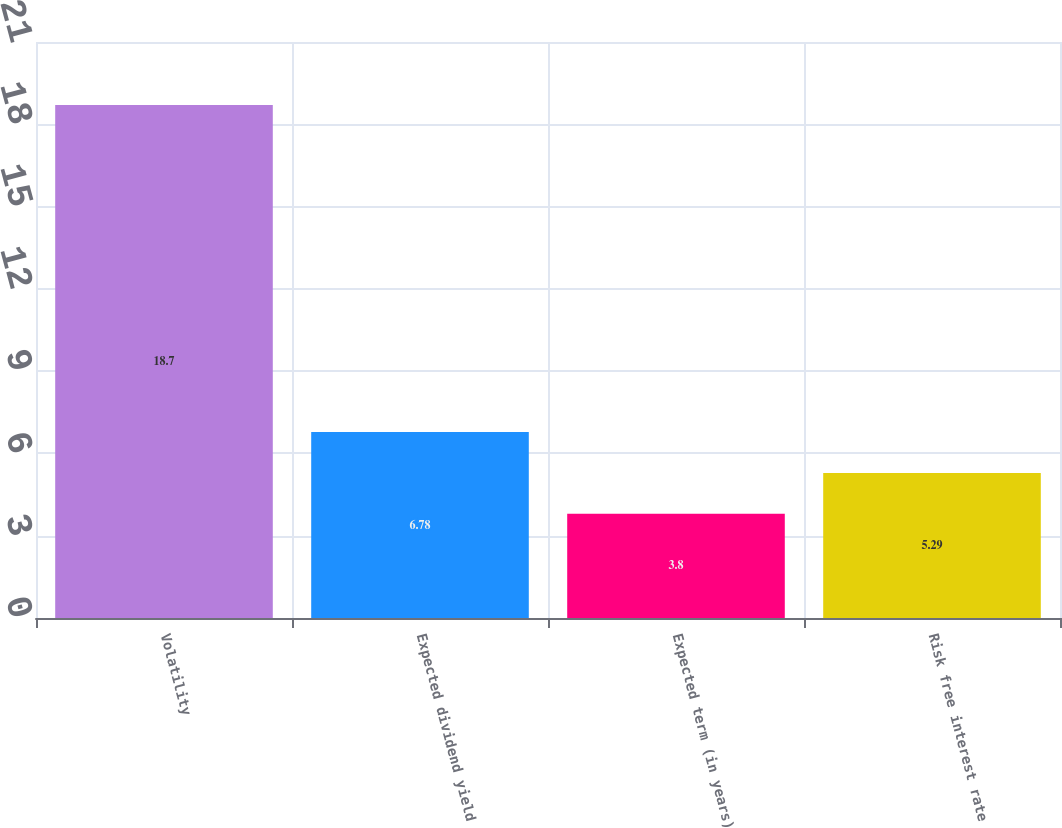Convert chart. <chart><loc_0><loc_0><loc_500><loc_500><bar_chart><fcel>Volatility<fcel>Expected dividend yield<fcel>Expected term (in years)<fcel>Risk free interest rate<nl><fcel>18.7<fcel>6.78<fcel>3.8<fcel>5.29<nl></chart> 